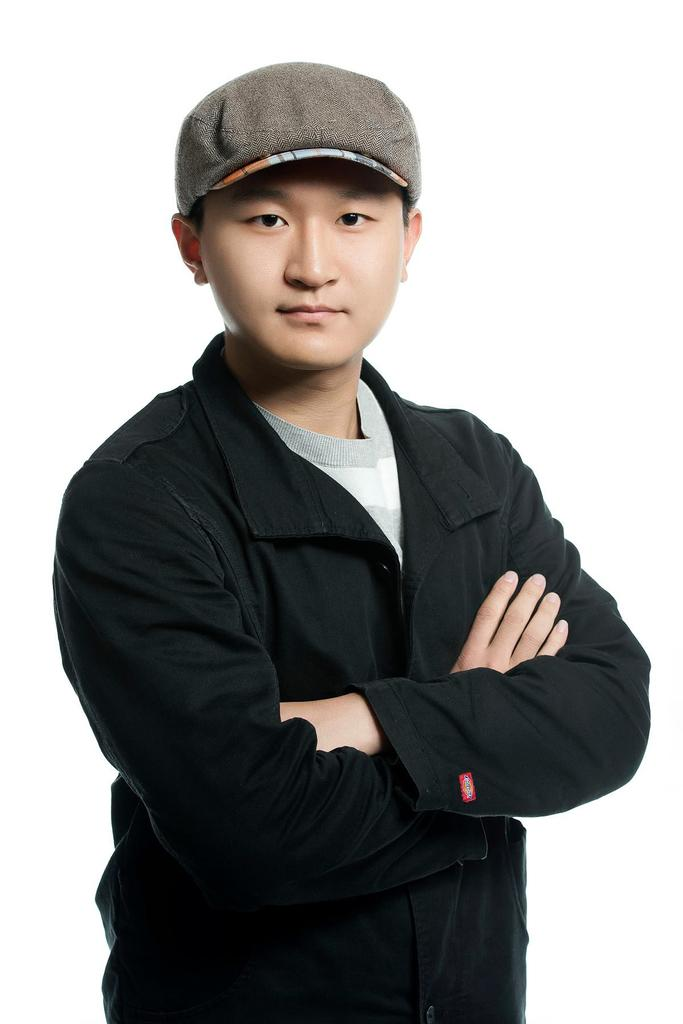What is the main subject of the image? There is a person in the image. What is the person doing in the image? The person is standing and posing for a photo. What type of quartz can be seen in the person's hand in the image? There is no quartz present in the image; the person is posing for a photo while standing. 